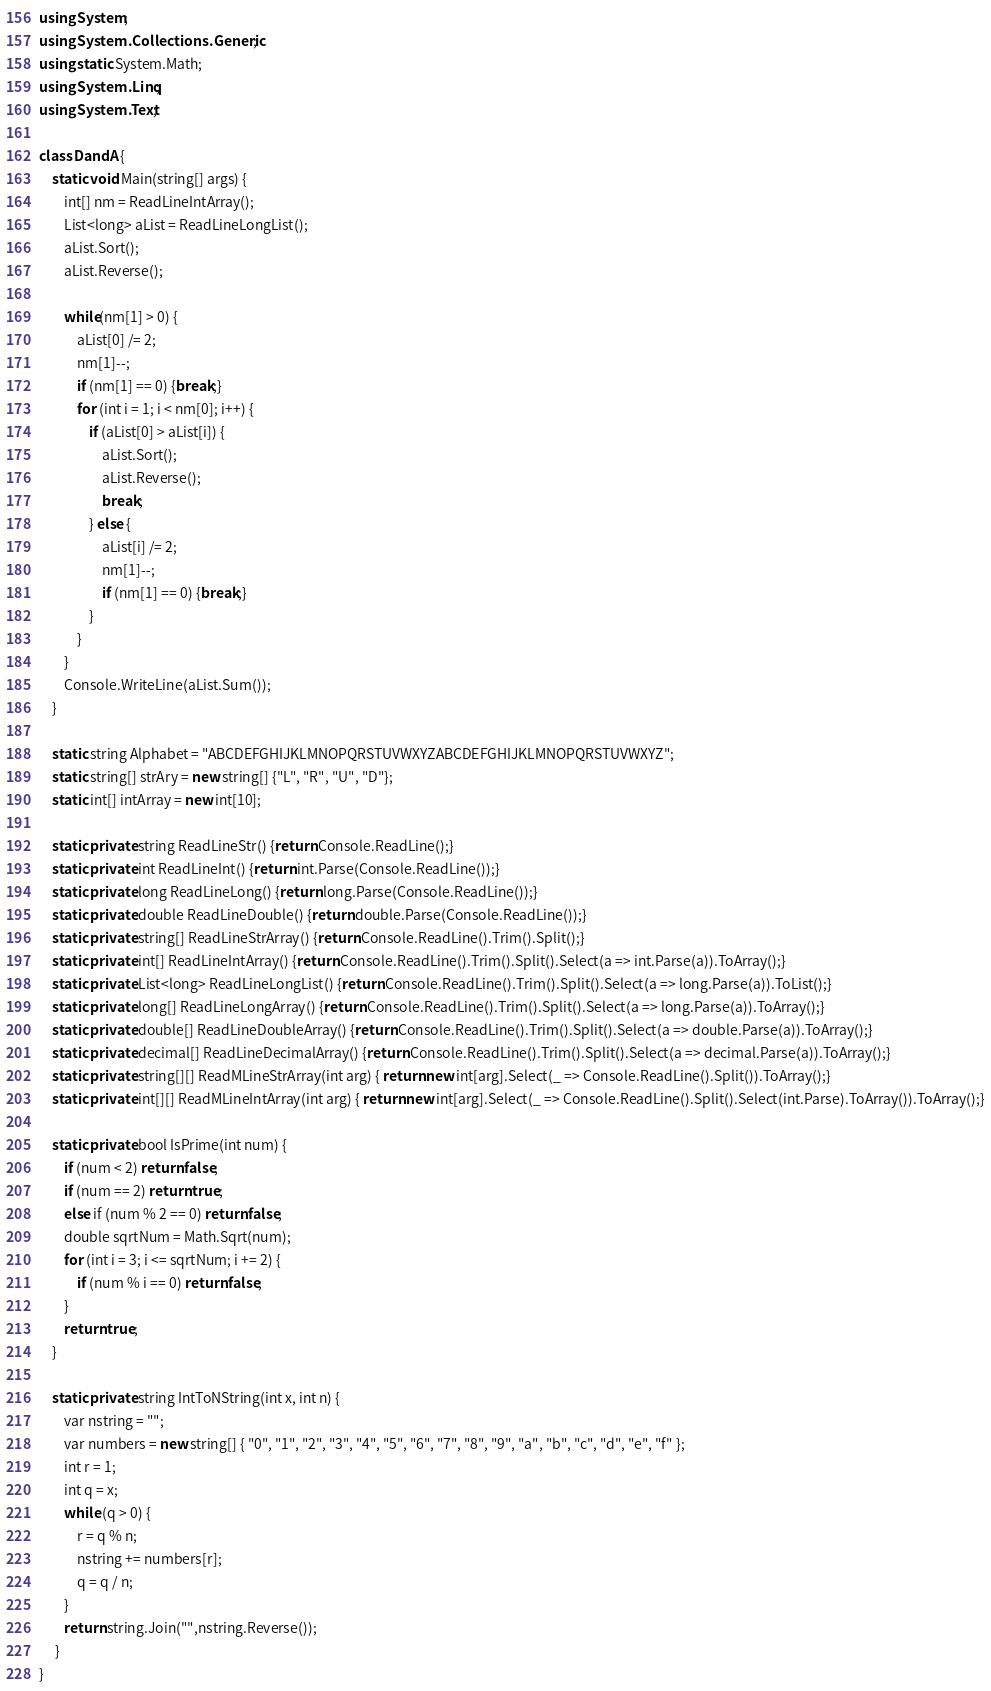Convert code to text. <code><loc_0><loc_0><loc_500><loc_500><_C#_>using System;
using System.Collections.Generic;
using static System.Math;
using System.Linq;
using System.Text;
 
class DandA {
    static void Main(string[] args) {
        int[] nm = ReadLineIntArray();
        List<long> aList = ReadLineLongList();
        aList.Sort();
        aList.Reverse();
 
        while(nm[1] > 0) {
            aList[0] /= 2;
            nm[1]--;
            if (nm[1] == 0) {break;}
            for (int i = 1; i < nm[0]; i++) {
                if (aList[0] > aList[i]) {
                    aList.Sort();
                    aList.Reverse();
                    break;
                } else {
                    aList[i] /= 2;
                    nm[1]--;
                    if (nm[1] == 0) {break;}
                }
            }
        }
        Console.WriteLine(aList.Sum());
    }
 
    static string Alphabet = "ABCDEFGHIJKLMNOPQRSTUVWXYZABCDEFGHIJKLMNOPQRSTUVWXYZ";
    static string[] strAry = new string[] {"L", "R", "U", "D"};
    static int[] intArray = new int[10];
  
    static private string ReadLineStr() {return Console.ReadLine();}
    static private int ReadLineInt() {return int.Parse(Console.ReadLine());}
    static private long ReadLineLong() {return long.Parse(Console.ReadLine());}
    static private double ReadLineDouble() {return double.Parse(Console.ReadLine());}
    static private string[] ReadLineStrArray() {return Console.ReadLine().Trim().Split();}
    static private int[] ReadLineIntArray() {return Console.ReadLine().Trim().Split().Select(a => int.Parse(a)).ToArray();}
    static private List<long> ReadLineLongList() {return Console.ReadLine().Trim().Split().Select(a => long.Parse(a)).ToList();}
    static private long[] ReadLineLongArray() {return Console.ReadLine().Trim().Split().Select(a => long.Parse(a)).ToArray();}
    static private double[] ReadLineDoubleArray() {return Console.ReadLine().Trim().Split().Select(a => double.Parse(a)).ToArray();}
    static private decimal[] ReadLineDecimalArray() {return Console.ReadLine().Trim().Split().Select(a => decimal.Parse(a)).ToArray();}
    static private string[][] ReadMLineStrArray(int arg) { return new int[arg].Select(_ => Console.ReadLine().Split()).ToArray();}
    static private int[][] ReadMLineIntArray(int arg) { return new int[arg].Select(_ => Console.ReadLine().Split().Select(int.Parse).ToArray()).ToArray();}
 
    static private bool IsPrime(int num) {
        if (num < 2) return false;
        if (num == 2) return true;
        else if (num % 2 == 0) return false;
        double sqrtNum = Math.Sqrt(num);
        for (int i = 3; i <= sqrtNum; i += 2) {
            if (num % i == 0) return false;
        }
        return true;
    }
  
    static private string IntToNString(int x, int n) {
        var nstring = "";
        var numbers = new string[] { "0", "1", "2", "3", "4", "5", "6", "7", "8", "9", "a", "b", "c", "d", "e", "f" };
        int r = 1;
        int q = x;
        while (q > 0) {
            r = q % n;
            nstring += numbers[r];
            q = q / n;
        }
        return string.Join("",nstring.Reverse());
     }
}</code> 